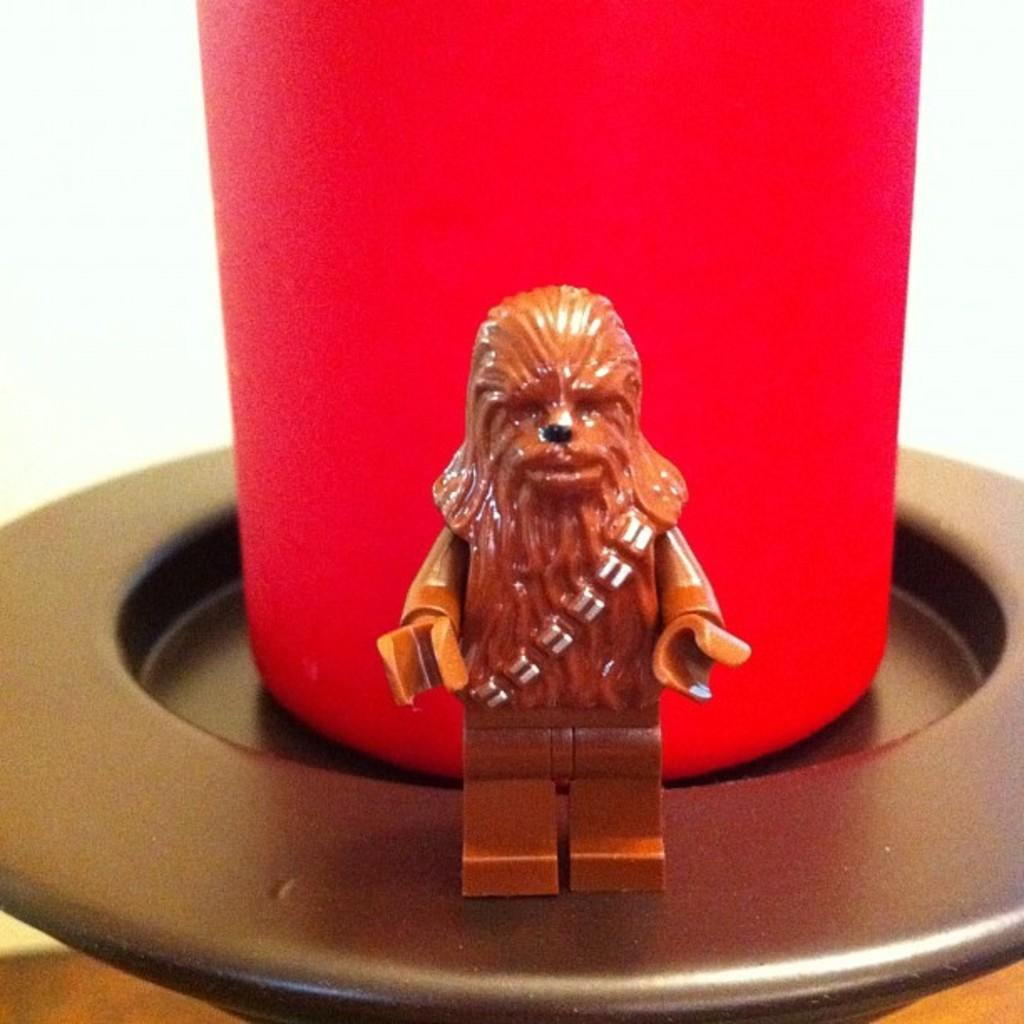What type of object can be seen in the image? There is a small sculpture in the image. What color is the glass in the image? The glass in the image is red. On what surface is the red glass placed? The red glass is on a black surface. What color is the other surface in the image? There is a white surface in the image. How does the wind affect the small sculpture in the image? There is no wind present in the image, so it cannot affect the small sculpture. What type of tree can be seen growing on the white surface in the image? There are no trees present in the image; it only features a small sculpture, a red glass, and two surfaces. 